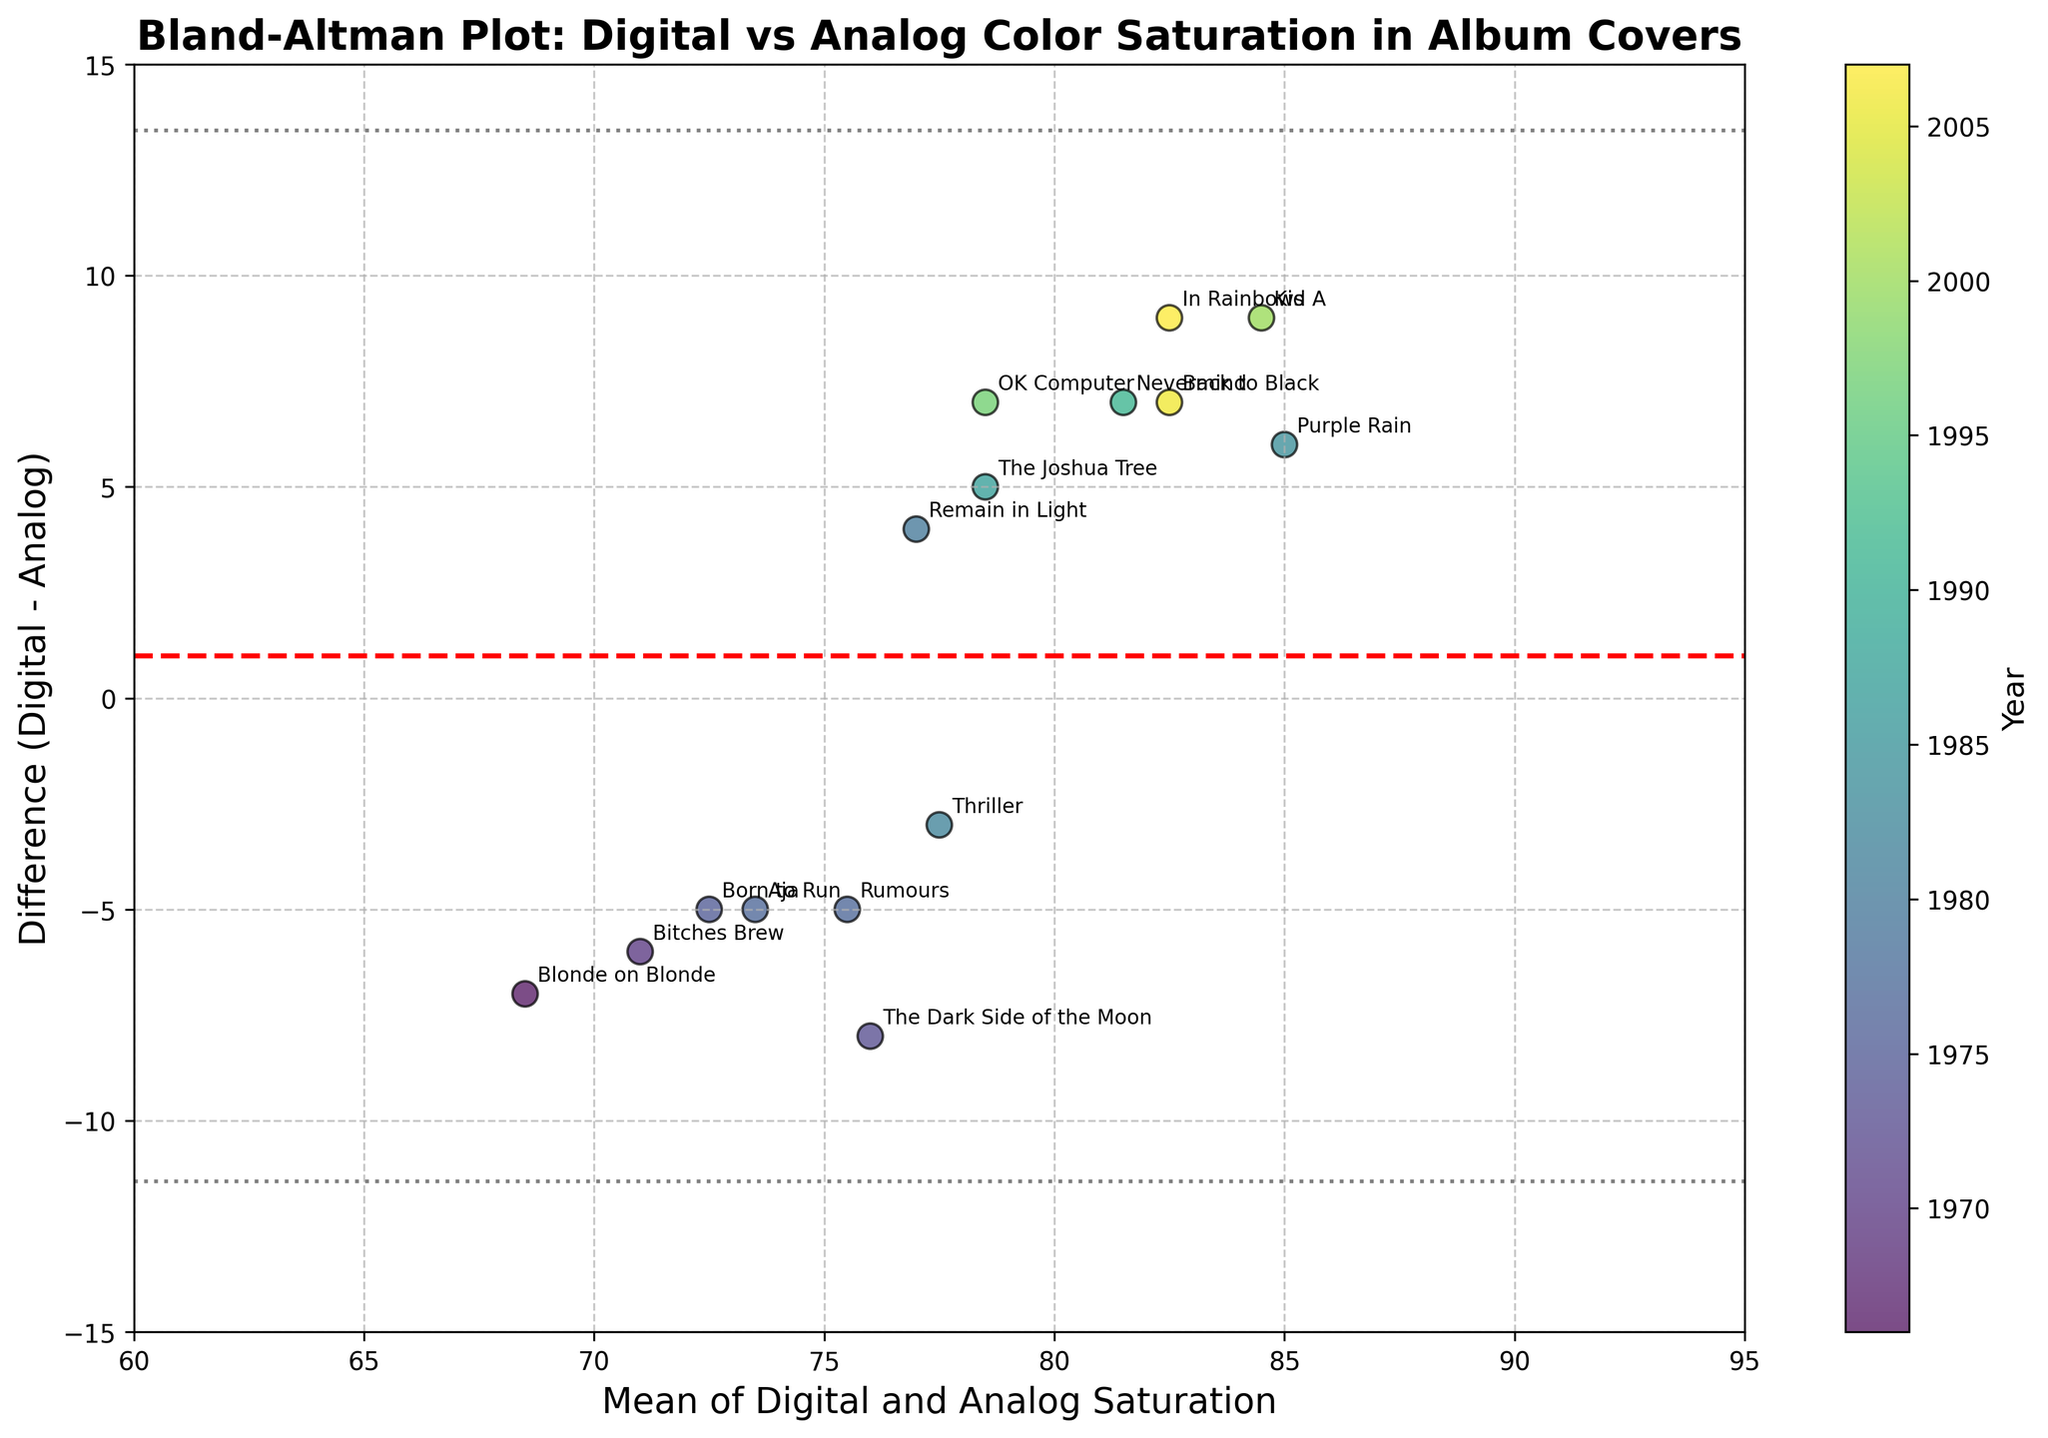What is the title of the plot? The title of the plot is usually displayed at the top of the figure. Here, the title reads: "Bland-Altman Plot: Digital vs Analog Color Saturation in Album Covers".
Answer: Bland-Altman Plot: Digital vs Analog Color Saturation in Album Covers What does the y-axis represent? The y-axis represents the difference between the digital and analog saturation levels, specifically the digital saturation minus the analog saturation.
Answer: Difference (Digital - Analog) What does the x-axis represent? The x-axis represents the mean of the digital and analog saturation levels for each album cover.
Answer: Mean of Digital and Analog Saturation How many data points are there in the plot? Each data point in the plot corresponds to an album cover. Counting each point, or referring to the number of album titles annotated on the plot, there are 15 data points.
Answer: 15 Which album cover has the highest digital saturation difference compared to its analog counterpart? By looking at the data points, the highest positive difference is shown by the album "Kid A" by Radiohead, which has a difference of 9.
Answer: Kid A Which year has a higher concentration of data points and which might indicate any trend in the plot? Observing the color gradient provided by the colormap, more data points are clustered in the lighter (more recent) colors, indicating that more album covers from the 2000s have been compared.
Answer: 2000s What is the mean difference between digital and analog color saturation, and how can you identify it? The mean difference is indicated by the red dashed line on the plot. The y-coordinate of this line is the mean of all differences.
Answer: 1.87 Between which years do the albums "Nevermind" and "Remain in Light" fall? The color gradient on the scatter plot corresponds to the colormap bar, which helps identify the range for specific years. By looking at the data points' color and referring to the colormap legend, "Nevermind" falls around 1990-1995, and "Remain in Light" around 1980-1985.
Answer: Around 1990-1995 and 1980-1985 respectively What is the standard deviation of the differences, and how is it represented visually? The standard deviation (SD) is used to plot the linear bands at ±1.96 SD from the mean difference. These are the gray dotted lines. The precise value can be calculated if needed, but its general impact is shown by these bands.
Answer: Represented by gray dotted lines Is there any data point for which the analog saturation is higher than the digital saturation? If yes, name one. Data points below the red dashed line represent cases where analog saturation is higher than digital. One such album is "The Dark Side of the Moon" by Pink Floyd.
Answer: The Dark Side of the Moon 